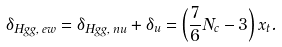<formula> <loc_0><loc_0><loc_500><loc_500>\delta _ { H g g , \, e w } = \delta _ { H g g , \, n u } + \delta _ { u } = \left ( \frac { 7 } { 6 } N _ { c } - 3 \right ) x _ { t } .</formula> 